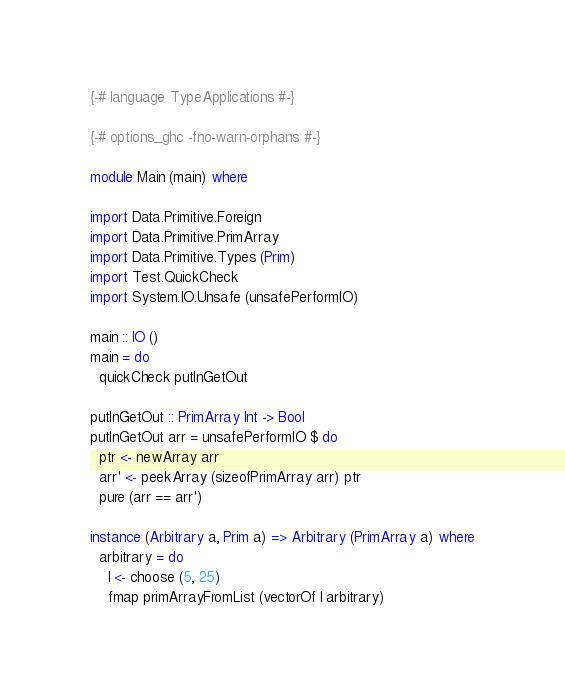Convert code to text. <code><loc_0><loc_0><loc_500><loc_500><_Haskell_>{-# language TypeApplications #-}

{-# options_ghc -fno-warn-orphans #-}

module Main (main) where

import Data.Primitive.Foreign
import Data.Primitive.PrimArray
import Data.Primitive.Types (Prim)
import Test.QuickCheck
import System.IO.Unsafe (unsafePerformIO)

main :: IO ()
main = do
  quickCheck putInGetOut

putInGetOut :: PrimArray Int -> Bool
putInGetOut arr = unsafePerformIO $ do
  ptr <- newArray arr
  arr' <- peekArray (sizeofPrimArray arr) ptr
  pure (arr == arr')

instance (Arbitrary a, Prim a) => Arbitrary (PrimArray a) where
  arbitrary = do
    l <- choose (5, 25)
    fmap primArrayFromList (vectorOf l arbitrary)
</code> 